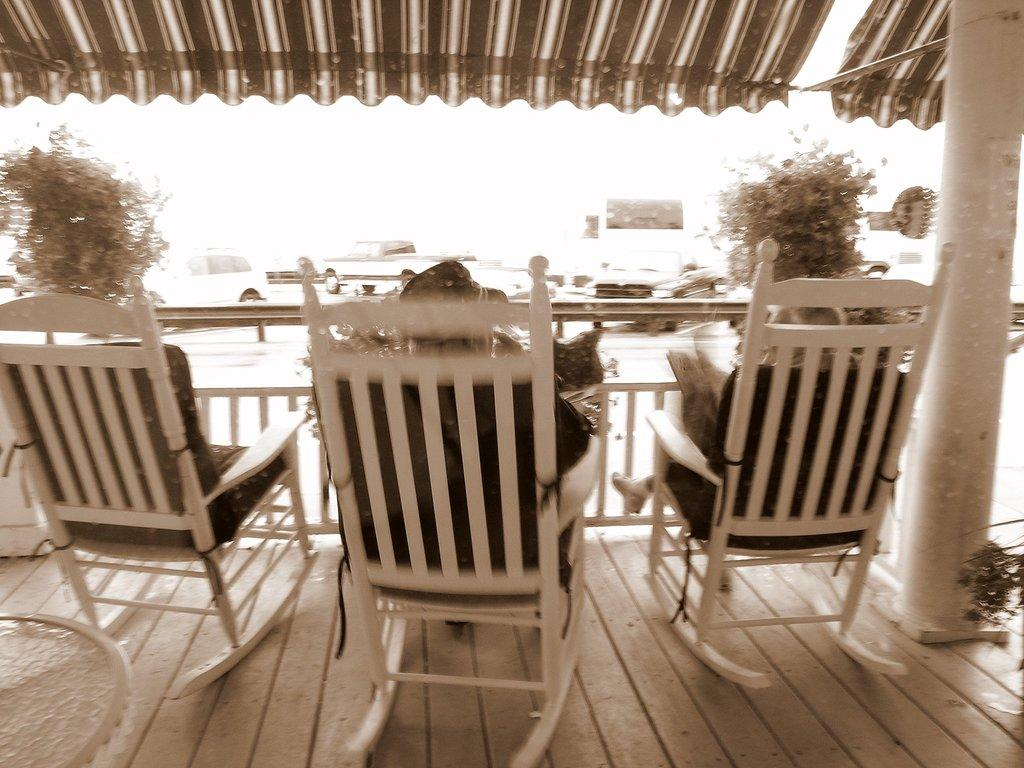How many people are sitting in the image? There are two persons sitting on chairs in the image. What else can be seen in the image besides the people? Vehicles, plants, the floor, chairs, and a pillar are visible in the image. Can you describe the type of vehicles in the image? The provided facts do not specify the type of vehicles in the image. What is the purpose of the chairs in the image? The chairs are being used for sitting by the two persons. What type of learning competition is taking place in the image? There is no learning competition present in the image. What type of plane can be seen flying in the image? There is no plane visible in the image. 